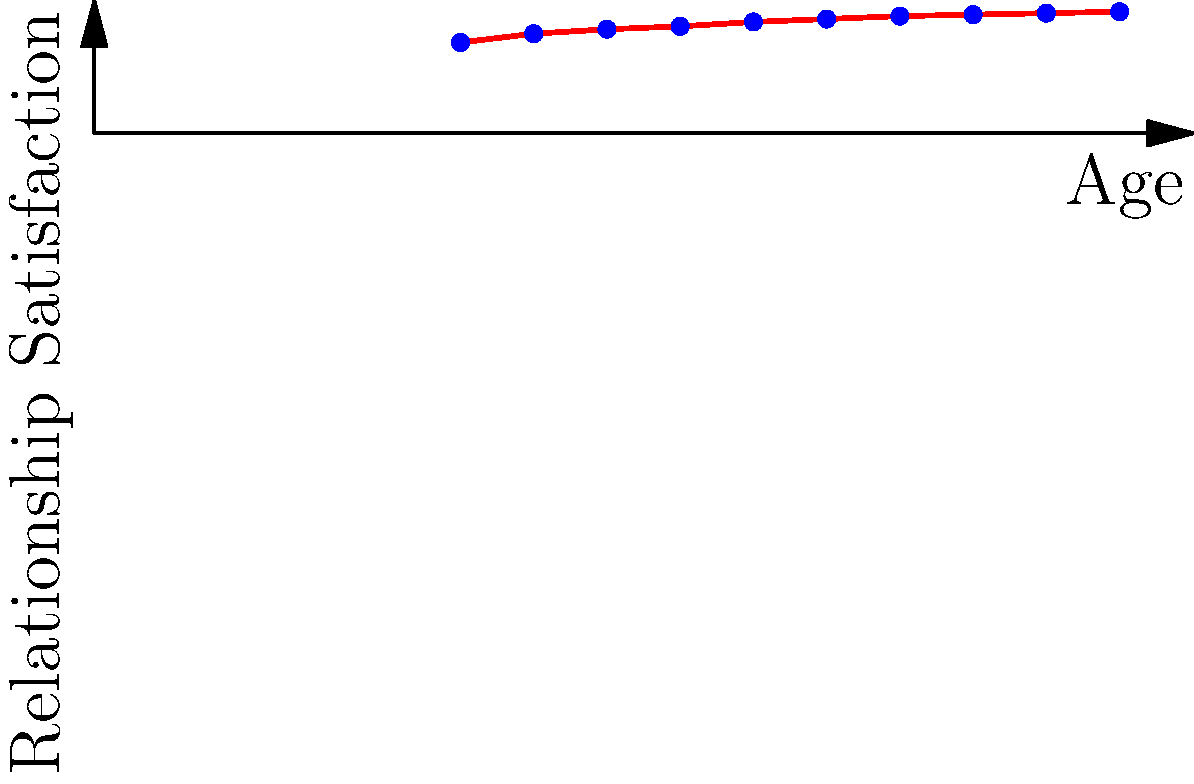Based on the scatter plot showing the correlation between relationship satisfaction and age, what can be inferred about the trend of relationship satisfaction as people age? To analyze the trend in relationship satisfaction as people age, we need to examine the scatter plot:

1. Observe the overall pattern: The dots form an upward trend from left to right.

2. Interpret the axes:
   - X-axis represents age, ranging from 25 to 70 years.
   - Y-axis represents relationship satisfaction, ranging from 0 to 9.

3. Analyze the data points:
   - At age 25, relationship satisfaction is around 6.2.
   - As age increases, relationship satisfaction generally increases.
   - The highest satisfaction level is around 8.3 at age 70.

4. Examine the slope:
   - The slope is steeper in the earlier years (25-40).
   - It becomes more gradual in later years (50-70).

5. Consider the correlation:
   - There is a positive correlation between age and relationship satisfaction.
   - As age increases, relationship satisfaction tends to increase.

6. Interpret the findings:
   - The data suggests that, on average, relationship satisfaction improves with age.
   - The improvement is more rapid in younger years and stabilizes in later years.

Given these observations, we can infer that there is a positive trend in relationship satisfaction as people age, with the rate of increase slowing down in later years.
Answer: Positive trend with age, rate of increase slowing in later years 